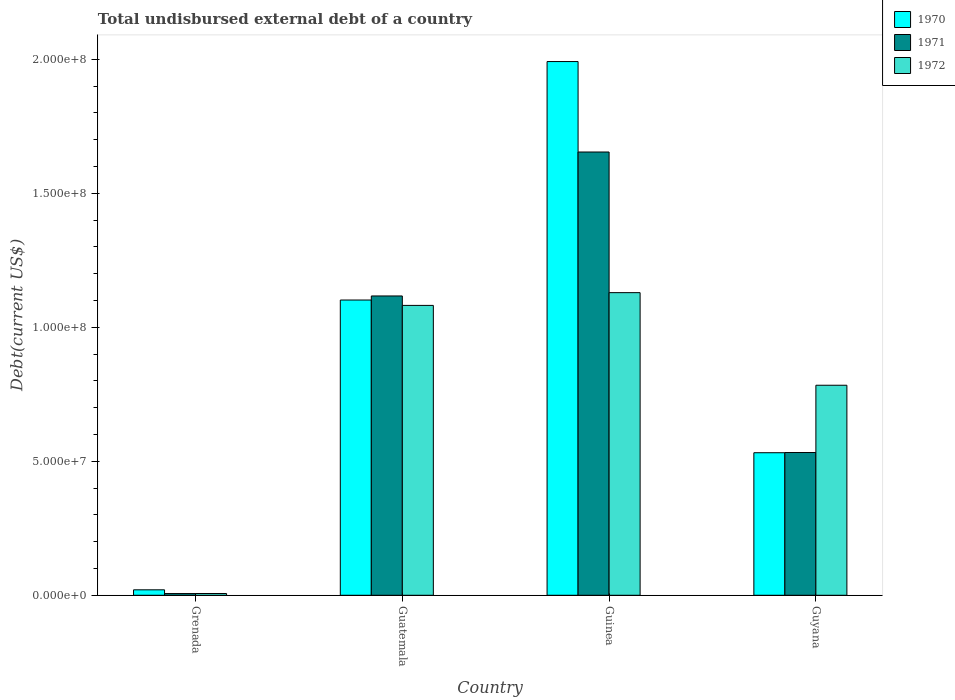Are the number of bars per tick equal to the number of legend labels?
Provide a short and direct response. Yes. Are the number of bars on each tick of the X-axis equal?
Your answer should be very brief. Yes. How many bars are there on the 3rd tick from the left?
Provide a short and direct response. 3. What is the label of the 4th group of bars from the left?
Offer a very short reply. Guyana. What is the total undisbursed external debt in 1971 in Grenada?
Offer a very short reply. 6.39e+05. Across all countries, what is the maximum total undisbursed external debt in 1970?
Your answer should be very brief. 1.99e+08. Across all countries, what is the minimum total undisbursed external debt in 1972?
Offer a terse response. 6.57e+05. In which country was the total undisbursed external debt in 1970 maximum?
Keep it short and to the point. Guinea. In which country was the total undisbursed external debt in 1970 minimum?
Offer a very short reply. Grenada. What is the total total undisbursed external debt in 1971 in the graph?
Ensure brevity in your answer.  3.31e+08. What is the difference between the total undisbursed external debt in 1972 in Guinea and that in Guyana?
Make the answer very short. 3.46e+07. What is the difference between the total undisbursed external debt in 1970 in Guinea and the total undisbursed external debt in 1972 in Guatemala?
Your response must be concise. 9.10e+07. What is the average total undisbursed external debt in 1972 per country?
Provide a succinct answer. 7.50e+07. What is the difference between the total undisbursed external debt of/in 1970 and total undisbursed external debt of/in 1971 in Grenada?
Provide a succinct answer. 1.40e+06. In how many countries, is the total undisbursed external debt in 1972 greater than 50000000 US$?
Ensure brevity in your answer.  3. What is the ratio of the total undisbursed external debt in 1970 in Guatemala to that in Guinea?
Keep it short and to the point. 0.55. Is the total undisbursed external debt in 1972 in Grenada less than that in Guyana?
Provide a short and direct response. Yes. Is the difference between the total undisbursed external debt in 1970 in Grenada and Guinea greater than the difference between the total undisbursed external debt in 1971 in Grenada and Guinea?
Ensure brevity in your answer.  No. What is the difference between the highest and the second highest total undisbursed external debt in 1970?
Your answer should be very brief. 1.46e+08. What is the difference between the highest and the lowest total undisbursed external debt in 1972?
Make the answer very short. 1.12e+08. What does the 1st bar from the left in Grenada represents?
Your answer should be very brief. 1970. What does the 2nd bar from the right in Guinea represents?
Your answer should be compact. 1971. Is it the case that in every country, the sum of the total undisbursed external debt in 1972 and total undisbursed external debt in 1970 is greater than the total undisbursed external debt in 1971?
Ensure brevity in your answer.  Yes. How many countries are there in the graph?
Your response must be concise. 4. What is the difference between two consecutive major ticks on the Y-axis?
Make the answer very short. 5.00e+07. Are the values on the major ticks of Y-axis written in scientific E-notation?
Your answer should be compact. Yes. Does the graph contain any zero values?
Provide a short and direct response. No. Does the graph contain grids?
Ensure brevity in your answer.  No. What is the title of the graph?
Your answer should be very brief. Total undisbursed external debt of a country. Does "2012" appear as one of the legend labels in the graph?
Your answer should be very brief. No. What is the label or title of the X-axis?
Provide a succinct answer. Country. What is the label or title of the Y-axis?
Provide a short and direct response. Debt(current US$). What is the Debt(current US$) in 1970 in Grenada?
Your response must be concise. 2.04e+06. What is the Debt(current US$) of 1971 in Grenada?
Make the answer very short. 6.39e+05. What is the Debt(current US$) of 1972 in Grenada?
Offer a very short reply. 6.57e+05. What is the Debt(current US$) in 1970 in Guatemala?
Offer a terse response. 1.10e+08. What is the Debt(current US$) in 1971 in Guatemala?
Make the answer very short. 1.12e+08. What is the Debt(current US$) of 1972 in Guatemala?
Offer a very short reply. 1.08e+08. What is the Debt(current US$) in 1970 in Guinea?
Offer a terse response. 1.99e+08. What is the Debt(current US$) of 1971 in Guinea?
Your answer should be very brief. 1.65e+08. What is the Debt(current US$) in 1972 in Guinea?
Provide a succinct answer. 1.13e+08. What is the Debt(current US$) of 1970 in Guyana?
Offer a terse response. 5.32e+07. What is the Debt(current US$) in 1971 in Guyana?
Your answer should be compact. 5.33e+07. What is the Debt(current US$) of 1972 in Guyana?
Offer a very short reply. 7.84e+07. Across all countries, what is the maximum Debt(current US$) in 1970?
Your response must be concise. 1.99e+08. Across all countries, what is the maximum Debt(current US$) in 1971?
Your answer should be very brief. 1.65e+08. Across all countries, what is the maximum Debt(current US$) in 1972?
Your answer should be very brief. 1.13e+08. Across all countries, what is the minimum Debt(current US$) of 1970?
Provide a succinct answer. 2.04e+06. Across all countries, what is the minimum Debt(current US$) of 1971?
Make the answer very short. 6.39e+05. Across all countries, what is the minimum Debt(current US$) in 1972?
Ensure brevity in your answer.  6.57e+05. What is the total Debt(current US$) of 1970 in the graph?
Make the answer very short. 3.65e+08. What is the total Debt(current US$) of 1971 in the graph?
Offer a terse response. 3.31e+08. What is the total Debt(current US$) in 1972 in the graph?
Your response must be concise. 3.00e+08. What is the difference between the Debt(current US$) of 1970 in Grenada and that in Guatemala?
Give a very brief answer. -1.08e+08. What is the difference between the Debt(current US$) of 1971 in Grenada and that in Guatemala?
Provide a succinct answer. -1.11e+08. What is the difference between the Debt(current US$) of 1972 in Grenada and that in Guatemala?
Your answer should be very brief. -1.08e+08. What is the difference between the Debt(current US$) of 1970 in Grenada and that in Guinea?
Offer a terse response. -1.97e+08. What is the difference between the Debt(current US$) in 1971 in Grenada and that in Guinea?
Give a very brief answer. -1.65e+08. What is the difference between the Debt(current US$) in 1972 in Grenada and that in Guinea?
Offer a very short reply. -1.12e+08. What is the difference between the Debt(current US$) in 1970 in Grenada and that in Guyana?
Offer a very short reply. -5.12e+07. What is the difference between the Debt(current US$) in 1971 in Grenada and that in Guyana?
Your answer should be very brief. -5.26e+07. What is the difference between the Debt(current US$) in 1972 in Grenada and that in Guyana?
Your answer should be compact. -7.77e+07. What is the difference between the Debt(current US$) in 1970 in Guatemala and that in Guinea?
Provide a succinct answer. -8.90e+07. What is the difference between the Debt(current US$) in 1971 in Guatemala and that in Guinea?
Offer a very short reply. -5.37e+07. What is the difference between the Debt(current US$) in 1972 in Guatemala and that in Guinea?
Offer a very short reply. -4.76e+06. What is the difference between the Debt(current US$) of 1970 in Guatemala and that in Guyana?
Your answer should be compact. 5.70e+07. What is the difference between the Debt(current US$) of 1971 in Guatemala and that in Guyana?
Keep it short and to the point. 5.84e+07. What is the difference between the Debt(current US$) in 1972 in Guatemala and that in Guyana?
Offer a very short reply. 2.98e+07. What is the difference between the Debt(current US$) of 1970 in Guinea and that in Guyana?
Your response must be concise. 1.46e+08. What is the difference between the Debt(current US$) in 1971 in Guinea and that in Guyana?
Your answer should be compact. 1.12e+08. What is the difference between the Debt(current US$) of 1972 in Guinea and that in Guyana?
Provide a short and direct response. 3.46e+07. What is the difference between the Debt(current US$) in 1970 in Grenada and the Debt(current US$) in 1971 in Guatemala?
Ensure brevity in your answer.  -1.10e+08. What is the difference between the Debt(current US$) of 1970 in Grenada and the Debt(current US$) of 1972 in Guatemala?
Provide a succinct answer. -1.06e+08. What is the difference between the Debt(current US$) in 1971 in Grenada and the Debt(current US$) in 1972 in Guatemala?
Your answer should be very brief. -1.08e+08. What is the difference between the Debt(current US$) in 1970 in Grenada and the Debt(current US$) in 1971 in Guinea?
Keep it short and to the point. -1.63e+08. What is the difference between the Debt(current US$) of 1970 in Grenada and the Debt(current US$) of 1972 in Guinea?
Provide a succinct answer. -1.11e+08. What is the difference between the Debt(current US$) of 1971 in Grenada and the Debt(current US$) of 1972 in Guinea?
Ensure brevity in your answer.  -1.12e+08. What is the difference between the Debt(current US$) in 1970 in Grenada and the Debt(current US$) in 1971 in Guyana?
Give a very brief answer. -5.12e+07. What is the difference between the Debt(current US$) of 1970 in Grenada and the Debt(current US$) of 1972 in Guyana?
Provide a succinct answer. -7.63e+07. What is the difference between the Debt(current US$) in 1971 in Grenada and the Debt(current US$) in 1972 in Guyana?
Your response must be concise. -7.77e+07. What is the difference between the Debt(current US$) of 1970 in Guatemala and the Debt(current US$) of 1971 in Guinea?
Make the answer very short. -5.52e+07. What is the difference between the Debt(current US$) of 1970 in Guatemala and the Debt(current US$) of 1972 in Guinea?
Provide a short and direct response. -2.75e+06. What is the difference between the Debt(current US$) of 1971 in Guatemala and the Debt(current US$) of 1972 in Guinea?
Your answer should be compact. -1.24e+06. What is the difference between the Debt(current US$) in 1970 in Guatemala and the Debt(current US$) in 1971 in Guyana?
Provide a short and direct response. 5.69e+07. What is the difference between the Debt(current US$) in 1970 in Guatemala and the Debt(current US$) in 1972 in Guyana?
Make the answer very short. 3.18e+07. What is the difference between the Debt(current US$) of 1971 in Guatemala and the Debt(current US$) of 1972 in Guyana?
Your answer should be compact. 3.33e+07. What is the difference between the Debt(current US$) in 1970 in Guinea and the Debt(current US$) in 1971 in Guyana?
Provide a succinct answer. 1.46e+08. What is the difference between the Debt(current US$) of 1970 in Guinea and the Debt(current US$) of 1972 in Guyana?
Provide a short and direct response. 1.21e+08. What is the difference between the Debt(current US$) of 1971 in Guinea and the Debt(current US$) of 1972 in Guyana?
Provide a succinct answer. 8.70e+07. What is the average Debt(current US$) in 1970 per country?
Your response must be concise. 9.11e+07. What is the average Debt(current US$) of 1971 per country?
Your response must be concise. 8.28e+07. What is the average Debt(current US$) in 1972 per country?
Provide a short and direct response. 7.50e+07. What is the difference between the Debt(current US$) in 1970 and Debt(current US$) in 1971 in Grenada?
Offer a terse response. 1.40e+06. What is the difference between the Debt(current US$) of 1970 and Debt(current US$) of 1972 in Grenada?
Provide a succinct answer. 1.38e+06. What is the difference between the Debt(current US$) in 1971 and Debt(current US$) in 1972 in Grenada?
Make the answer very short. -1.80e+04. What is the difference between the Debt(current US$) of 1970 and Debt(current US$) of 1971 in Guatemala?
Your response must be concise. -1.52e+06. What is the difference between the Debt(current US$) of 1970 and Debt(current US$) of 1972 in Guatemala?
Give a very brief answer. 2.01e+06. What is the difference between the Debt(current US$) of 1971 and Debt(current US$) of 1972 in Guatemala?
Your response must be concise. 3.52e+06. What is the difference between the Debt(current US$) of 1970 and Debt(current US$) of 1971 in Guinea?
Provide a succinct answer. 3.38e+07. What is the difference between the Debt(current US$) of 1970 and Debt(current US$) of 1972 in Guinea?
Make the answer very short. 8.62e+07. What is the difference between the Debt(current US$) of 1971 and Debt(current US$) of 1972 in Guinea?
Provide a short and direct response. 5.25e+07. What is the difference between the Debt(current US$) in 1970 and Debt(current US$) in 1971 in Guyana?
Your answer should be compact. -7.30e+04. What is the difference between the Debt(current US$) of 1970 and Debt(current US$) of 1972 in Guyana?
Your response must be concise. -2.52e+07. What is the difference between the Debt(current US$) in 1971 and Debt(current US$) in 1972 in Guyana?
Give a very brief answer. -2.51e+07. What is the ratio of the Debt(current US$) of 1970 in Grenada to that in Guatemala?
Keep it short and to the point. 0.02. What is the ratio of the Debt(current US$) in 1971 in Grenada to that in Guatemala?
Provide a short and direct response. 0.01. What is the ratio of the Debt(current US$) in 1972 in Grenada to that in Guatemala?
Your response must be concise. 0.01. What is the ratio of the Debt(current US$) in 1970 in Grenada to that in Guinea?
Ensure brevity in your answer.  0.01. What is the ratio of the Debt(current US$) in 1971 in Grenada to that in Guinea?
Offer a terse response. 0. What is the ratio of the Debt(current US$) in 1972 in Grenada to that in Guinea?
Your answer should be compact. 0.01. What is the ratio of the Debt(current US$) in 1970 in Grenada to that in Guyana?
Offer a very short reply. 0.04. What is the ratio of the Debt(current US$) of 1971 in Grenada to that in Guyana?
Your answer should be very brief. 0.01. What is the ratio of the Debt(current US$) in 1972 in Grenada to that in Guyana?
Ensure brevity in your answer.  0.01. What is the ratio of the Debt(current US$) in 1970 in Guatemala to that in Guinea?
Your answer should be compact. 0.55. What is the ratio of the Debt(current US$) in 1971 in Guatemala to that in Guinea?
Your answer should be very brief. 0.68. What is the ratio of the Debt(current US$) of 1972 in Guatemala to that in Guinea?
Provide a succinct answer. 0.96. What is the ratio of the Debt(current US$) in 1970 in Guatemala to that in Guyana?
Your answer should be compact. 2.07. What is the ratio of the Debt(current US$) in 1971 in Guatemala to that in Guyana?
Provide a short and direct response. 2.1. What is the ratio of the Debt(current US$) in 1972 in Guatemala to that in Guyana?
Your answer should be compact. 1.38. What is the ratio of the Debt(current US$) in 1970 in Guinea to that in Guyana?
Your answer should be compact. 3.74. What is the ratio of the Debt(current US$) of 1971 in Guinea to that in Guyana?
Give a very brief answer. 3.11. What is the ratio of the Debt(current US$) of 1972 in Guinea to that in Guyana?
Provide a short and direct response. 1.44. What is the difference between the highest and the second highest Debt(current US$) in 1970?
Your answer should be very brief. 8.90e+07. What is the difference between the highest and the second highest Debt(current US$) in 1971?
Offer a very short reply. 5.37e+07. What is the difference between the highest and the second highest Debt(current US$) in 1972?
Provide a succinct answer. 4.76e+06. What is the difference between the highest and the lowest Debt(current US$) in 1970?
Keep it short and to the point. 1.97e+08. What is the difference between the highest and the lowest Debt(current US$) of 1971?
Make the answer very short. 1.65e+08. What is the difference between the highest and the lowest Debt(current US$) in 1972?
Your answer should be compact. 1.12e+08. 